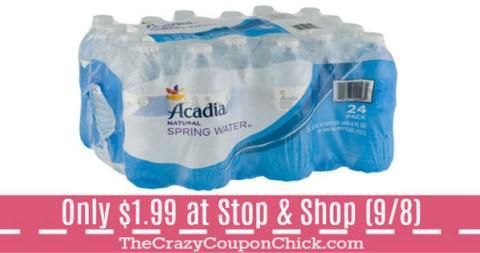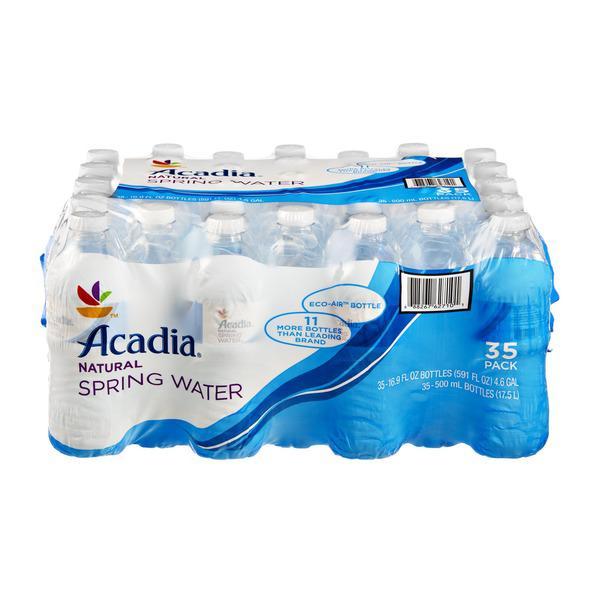The first image is the image on the left, the second image is the image on the right. For the images shown, is this caption "There are water bottles with two or more different labels and shapes." true? Answer yes or no. No. The first image is the image on the left, the second image is the image on the right. Given the left and right images, does the statement "The left and right image contains at least eight bottle of water in a plastic wrap." hold true? Answer yes or no. Yes. 